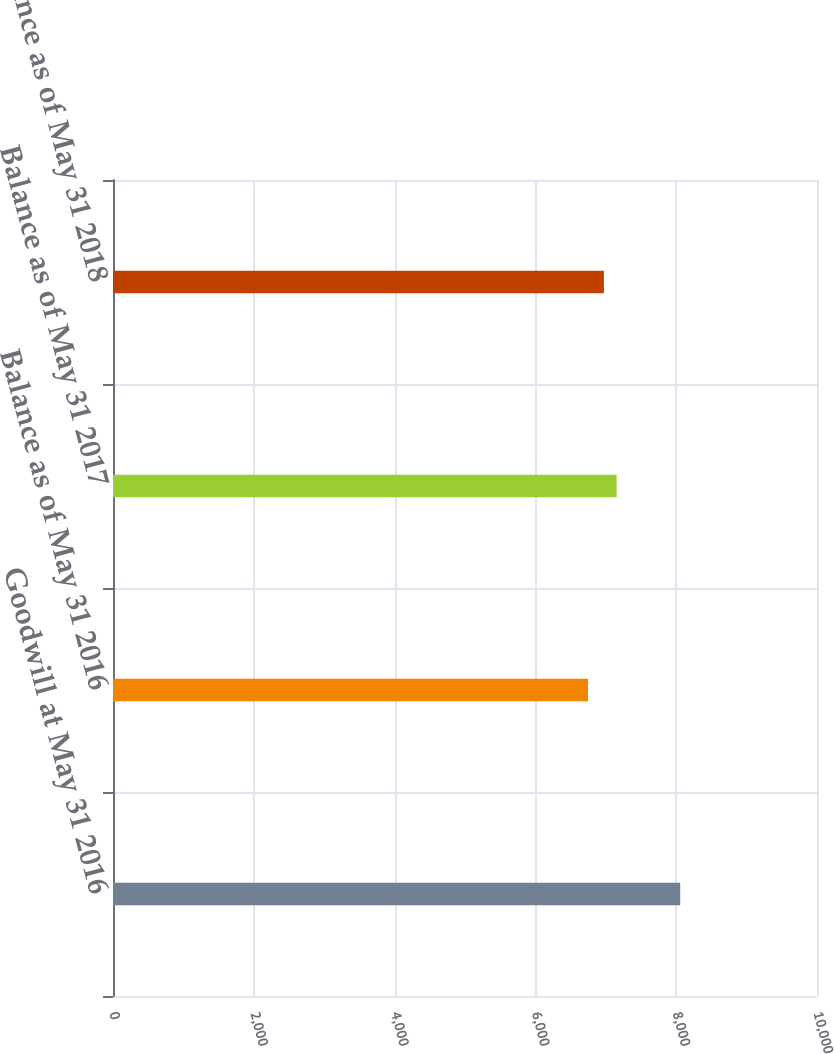Convert chart to OTSL. <chart><loc_0><loc_0><loc_500><loc_500><bar_chart><fcel>Goodwill at May 31 2016<fcel>Balance as of May 31 2016<fcel>Balance as of May 31 2017<fcel>Balance as of May 31 2018<nl><fcel>8057<fcel>6747<fcel>7154<fcel>6973<nl></chart> 